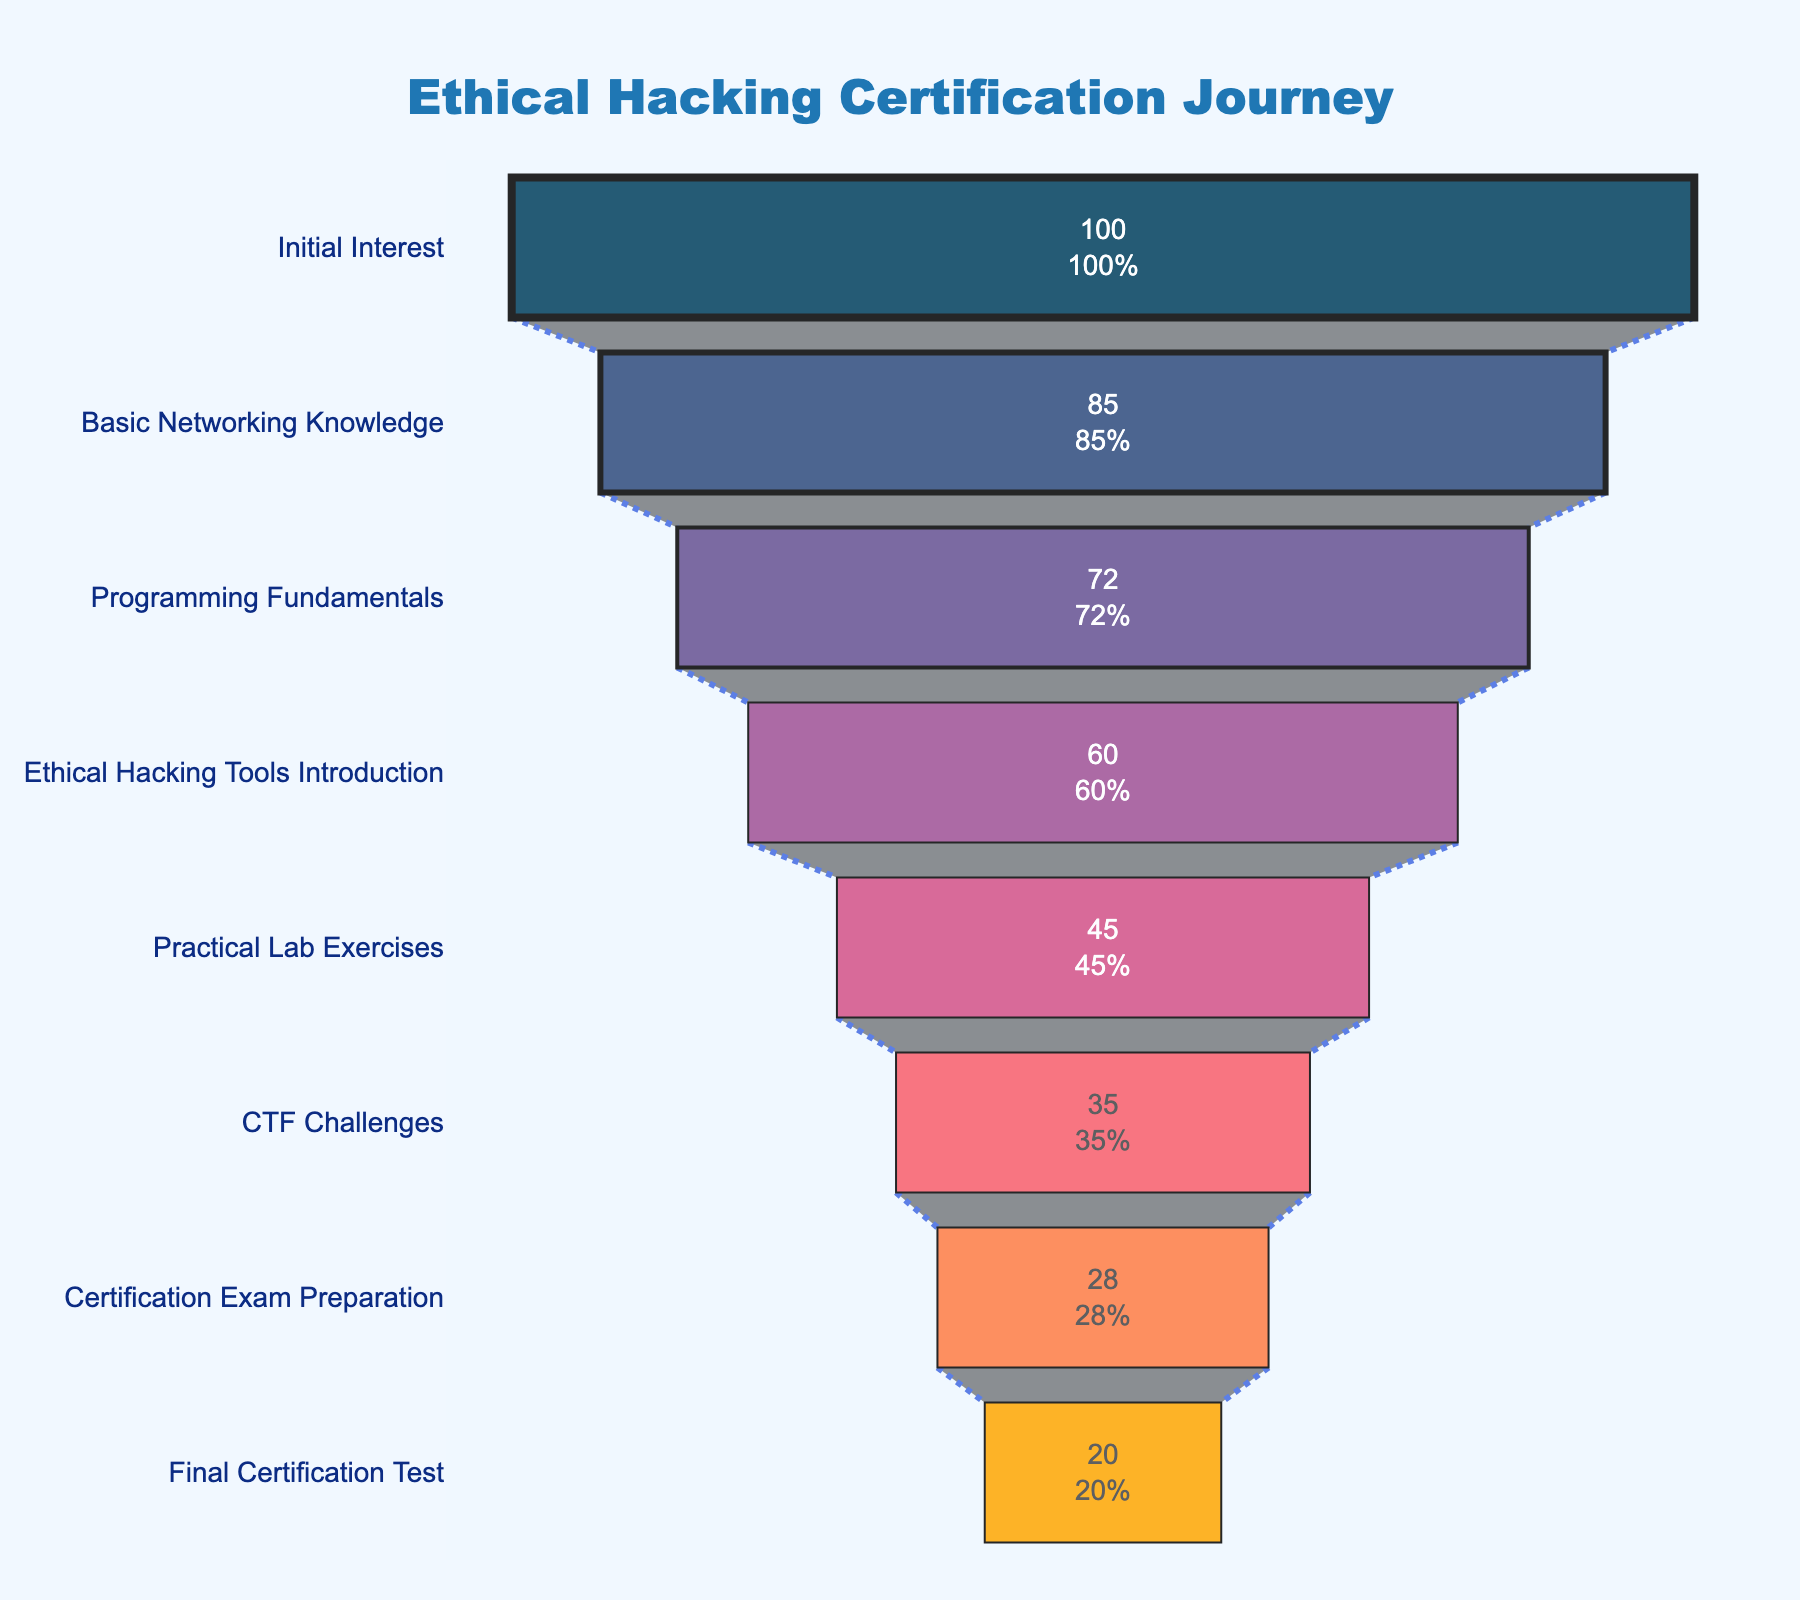How many stages are there in the ethical hacking certification process? The figure has multiple horizontal segments representing different stages in the certification process. By counting these segments, we can determine the total number of stages.
Answer: 8 What is the title of the figure? The title is displayed prominently at the top of the figure.
Answer: Ethical Hacking Certification Journey How many candidates remain after the final certification test? This value is shown inside the final segment of the funnel chart, which represents the number of candidates at the last stage.
Answer: 20 How many candidates drop out after the Practical Lab Exercises? Subtract the number of candidates at the CTF Challenges stage from the number at the Practical Lab Exercises stage to find the drop. 45 (Practical Lab Exercises) - 35 (CTF Challenges) = 10
Answer: 10 What percentage of initial candidates reach the Certification Exam Preparation stage? The chart shows that the Certification Exam Preparation segment has 28 candidates. To find the percentage, divide this number by the initial candidates and multiply by 100. (28/100) * 100 = 28%
Answer: 28% Which stage has the largest drop-off in the number of candidates? Compare the number of candidates between consecutive stages to find the largest difference. The largest drop-off is between Initial Interest (100) and Basic Networking Knowledge (85), which is a loss of 15 candidates.
Answer: Initial Interest to Basic Networking Knowledge True or False: More than half of the candidates who are interested initially make it to the Ethical Hacking Tools Introduction stage. Check the percentage of candidates at the Ethical Hacking Tools Introduction stage relative to the initial interest. 60 over the initial 100 is 60%, which is more than half.
Answer: True How many fewer candidates are there at the Programming Fundamentals stage compared to the Ethical Hacking Tools Introduction stage? Subtract the number of candidates at Programming Fundamentals (72) from the number at Ethical Hacking Tools Introduction (60). 72 - 60 = 12
Answer: 12 Which stage sees the smallest number of candidates progressing to it? Look at the segment with the smallest number of candidates, which corresponds to the final certification test with 20 candidates.
Answer: Final Certification Test What is the total number of candidates lost from Initial Interest to the final stage? Subtract the number at the Final Certification Test (20) from the number at Initial Interest (100). 100 - 20 = 80
Answer: 80 